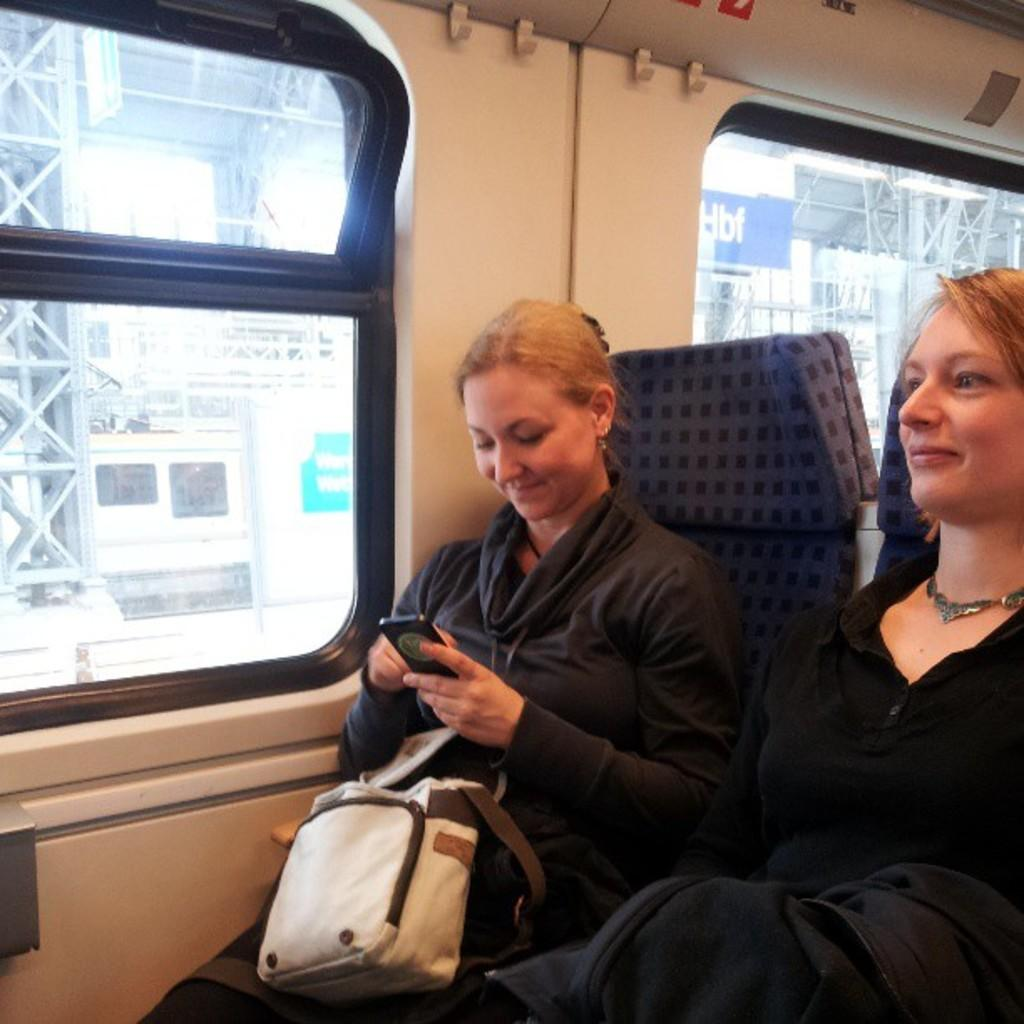How many women are in the image? There are two women in the image. What are the women doing in the image? The women are sitting on chairs. What can be seen on the left side of the image? There is a glass window on the left side of the image. Where does the setting of the image appear to be? The setting appears to be inside a train. Can you tell me what idea the ant is discussing with the women in the image? There is no ant present in the image, so it is not possible to determine what idea the ant might be discussing with the women. 